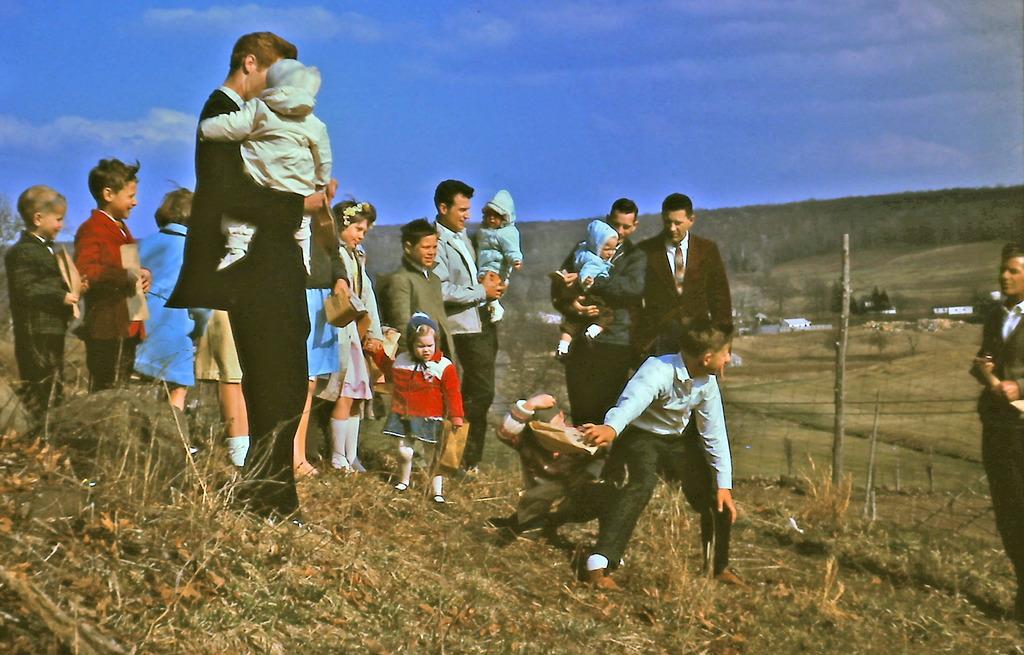Could you give a brief overview of what you see in this image? In this image we can see few persons are standing on the ground and among them few persons are holding kids in their hands. In the background we can see houses, trees on the hills and clouds in the sky. 